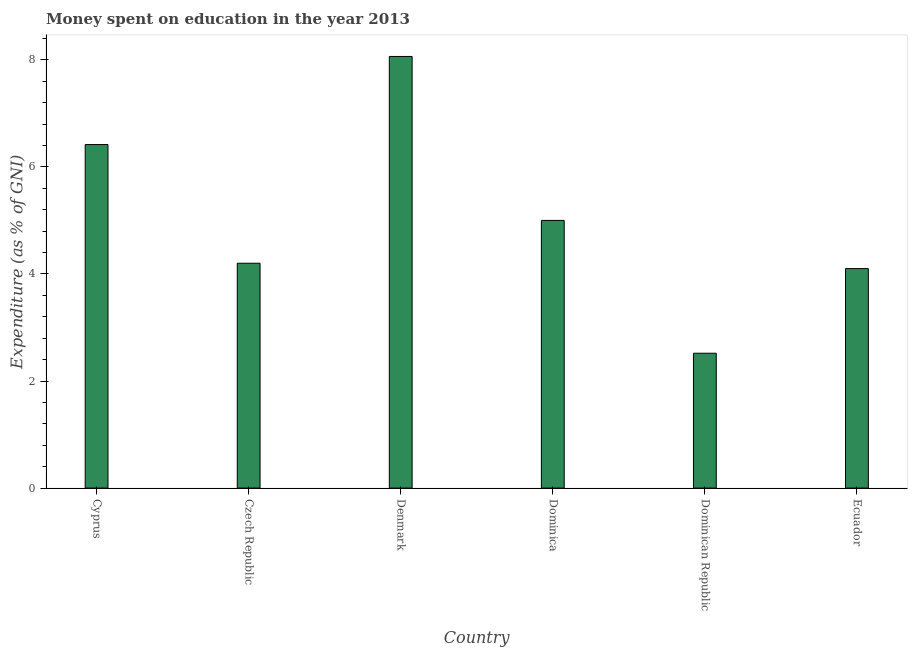Does the graph contain any zero values?
Your answer should be very brief. No. What is the title of the graph?
Offer a very short reply. Money spent on education in the year 2013. What is the label or title of the Y-axis?
Ensure brevity in your answer.  Expenditure (as % of GNI). What is the expenditure on education in Dominican Republic?
Make the answer very short. 2.52. Across all countries, what is the maximum expenditure on education?
Provide a succinct answer. 8.06. Across all countries, what is the minimum expenditure on education?
Make the answer very short. 2.52. In which country was the expenditure on education minimum?
Your answer should be very brief. Dominican Republic. What is the sum of the expenditure on education?
Make the answer very short. 30.3. What is the difference between the expenditure on education in Dominican Republic and Ecuador?
Ensure brevity in your answer.  -1.58. What is the average expenditure on education per country?
Provide a succinct answer. 5.05. In how many countries, is the expenditure on education greater than 6.8 %?
Make the answer very short. 1. What is the ratio of the expenditure on education in Denmark to that in Ecuador?
Offer a very short reply. 1.97. Is the expenditure on education in Czech Republic less than that in Ecuador?
Offer a very short reply. No. What is the difference between the highest and the second highest expenditure on education?
Offer a terse response. 1.65. Is the sum of the expenditure on education in Czech Republic and Ecuador greater than the maximum expenditure on education across all countries?
Provide a succinct answer. Yes. What is the difference between the highest and the lowest expenditure on education?
Offer a very short reply. 5.54. In how many countries, is the expenditure on education greater than the average expenditure on education taken over all countries?
Your response must be concise. 2. How many bars are there?
Your answer should be very brief. 6. Are all the bars in the graph horizontal?
Provide a short and direct response. No. What is the Expenditure (as % of GNI) of Cyprus?
Offer a very short reply. 6.42. What is the Expenditure (as % of GNI) of Denmark?
Make the answer very short. 8.06. What is the Expenditure (as % of GNI) of Dominican Republic?
Ensure brevity in your answer.  2.52. What is the difference between the Expenditure (as % of GNI) in Cyprus and Czech Republic?
Your response must be concise. 2.22. What is the difference between the Expenditure (as % of GNI) in Cyprus and Denmark?
Make the answer very short. -1.65. What is the difference between the Expenditure (as % of GNI) in Cyprus and Dominica?
Provide a short and direct response. 1.42. What is the difference between the Expenditure (as % of GNI) in Cyprus and Dominican Republic?
Keep it short and to the point. 3.9. What is the difference between the Expenditure (as % of GNI) in Cyprus and Ecuador?
Ensure brevity in your answer.  2.32. What is the difference between the Expenditure (as % of GNI) in Czech Republic and Denmark?
Make the answer very short. -3.86. What is the difference between the Expenditure (as % of GNI) in Czech Republic and Dominican Republic?
Your answer should be very brief. 1.68. What is the difference between the Expenditure (as % of GNI) in Denmark and Dominica?
Your answer should be very brief. 3.06. What is the difference between the Expenditure (as % of GNI) in Denmark and Dominican Republic?
Offer a terse response. 5.54. What is the difference between the Expenditure (as % of GNI) in Denmark and Ecuador?
Offer a very short reply. 3.96. What is the difference between the Expenditure (as % of GNI) in Dominica and Dominican Republic?
Make the answer very short. 2.48. What is the difference between the Expenditure (as % of GNI) in Dominica and Ecuador?
Your answer should be very brief. 0.9. What is the difference between the Expenditure (as % of GNI) in Dominican Republic and Ecuador?
Offer a very short reply. -1.58. What is the ratio of the Expenditure (as % of GNI) in Cyprus to that in Czech Republic?
Provide a short and direct response. 1.53. What is the ratio of the Expenditure (as % of GNI) in Cyprus to that in Denmark?
Provide a succinct answer. 0.8. What is the ratio of the Expenditure (as % of GNI) in Cyprus to that in Dominica?
Your answer should be compact. 1.28. What is the ratio of the Expenditure (as % of GNI) in Cyprus to that in Dominican Republic?
Your answer should be very brief. 2.55. What is the ratio of the Expenditure (as % of GNI) in Cyprus to that in Ecuador?
Your answer should be very brief. 1.56. What is the ratio of the Expenditure (as % of GNI) in Czech Republic to that in Denmark?
Ensure brevity in your answer.  0.52. What is the ratio of the Expenditure (as % of GNI) in Czech Republic to that in Dominica?
Keep it short and to the point. 0.84. What is the ratio of the Expenditure (as % of GNI) in Czech Republic to that in Dominican Republic?
Your response must be concise. 1.67. What is the ratio of the Expenditure (as % of GNI) in Czech Republic to that in Ecuador?
Your answer should be very brief. 1.02. What is the ratio of the Expenditure (as % of GNI) in Denmark to that in Dominica?
Provide a short and direct response. 1.61. What is the ratio of the Expenditure (as % of GNI) in Denmark to that in Ecuador?
Give a very brief answer. 1.97. What is the ratio of the Expenditure (as % of GNI) in Dominica to that in Dominican Republic?
Your answer should be very brief. 1.99. What is the ratio of the Expenditure (as % of GNI) in Dominica to that in Ecuador?
Offer a terse response. 1.22. What is the ratio of the Expenditure (as % of GNI) in Dominican Republic to that in Ecuador?
Your answer should be compact. 0.61. 